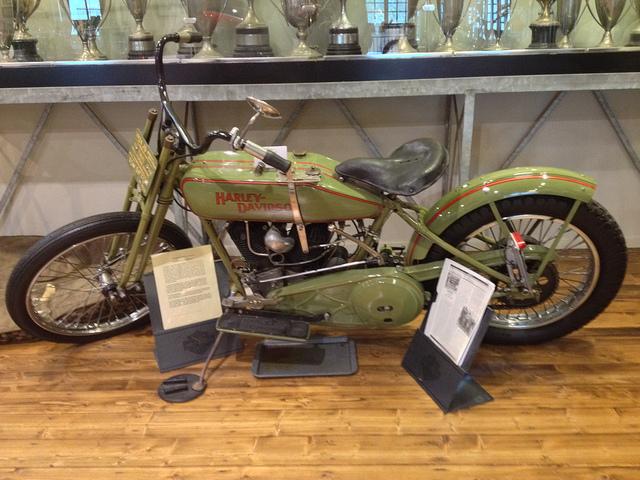What company made this motorcycle?
Be succinct. Harley davidson. Which year was this motorcycle introduced for sale?
Answer briefly. 1967. Is this a toy motorbike?
Answer briefly. No. 